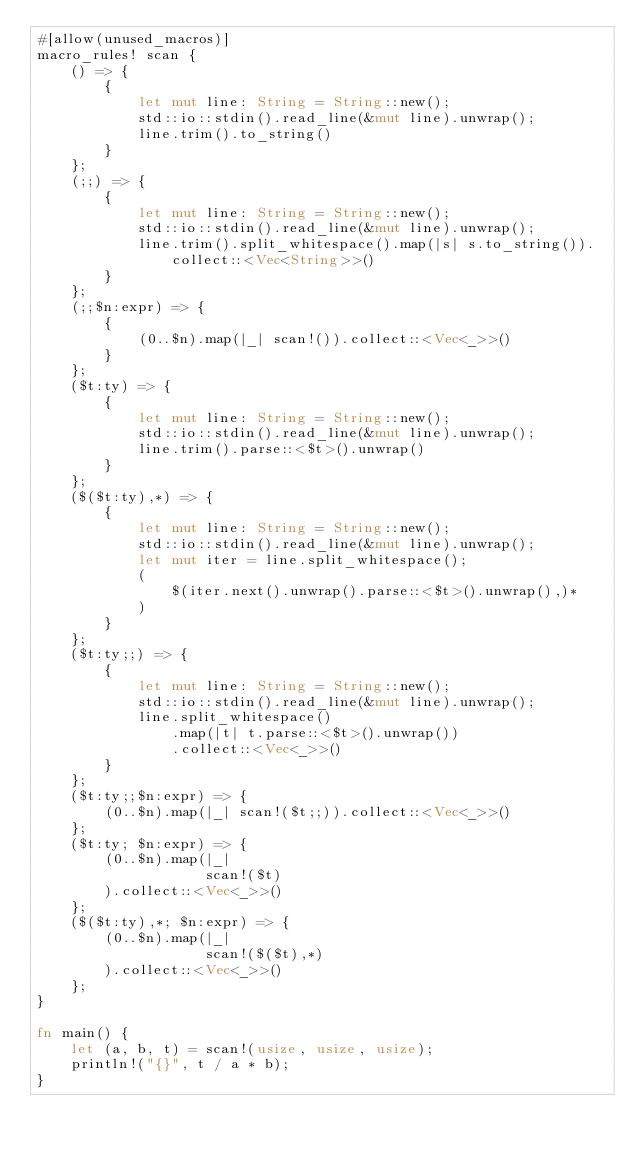<code> <loc_0><loc_0><loc_500><loc_500><_Rust_>#[allow(unused_macros)]
macro_rules! scan {
    () => {
        {
            let mut line: String = String::new();
            std::io::stdin().read_line(&mut line).unwrap();
            line.trim().to_string()
        }
    };
    (;;) => {
        {
            let mut line: String = String::new();
            std::io::stdin().read_line(&mut line).unwrap();
            line.trim().split_whitespace().map(|s| s.to_string()).collect::<Vec<String>>()
        }
    };
    (;;$n:expr) => {
        {
            (0..$n).map(|_| scan!()).collect::<Vec<_>>()
        }
    };
    ($t:ty) => {
        {
            let mut line: String = String::new();
            std::io::stdin().read_line(&mut line).unwrap();
            line.trim().parse::<$t>().unwrap()
        }
    };
    ($($t:ty),*) => {
        {
            let mut line: String = String::new();
            std::io::stdin().read_line(&mut line).unwrap();
            let mut iter = line.split_whitespace();
            (
                $(iter.next().unwrap().parse::<$t>().unwrap(),)*
            )
        }
    };
    ($t:ty;;) => {
        {
            let mut line: String = String::new();
            std::io::stdin().read_line(&mut line).unwrap();
            line.split_whitespace()
                .map(|t| t.parse::<$t>().unwrap())
                .collect::<Vec<_>>()
        }
    };
    ($t:ty;;$n:expr) => {
        (0..$n).map(|_| scan!($t;;)).collect::<Vec<_>>()
    };
    ($t:ty; $n:expr) => {
        (0..$n).map(|_|
                    scan!($t)
        ).collect::<Vec<_>>()
    };
    ($($t:ty),*; $n:expr) => {
        (0..$n).map(|_|
                    scan!($($t),*)
        ).collect::<Vec<_>>()
    };
}

fn main() {
    let (a, b, t) = scan!(usize, usize, usize);
    println!("{}", t / a * b);
}
</code> 